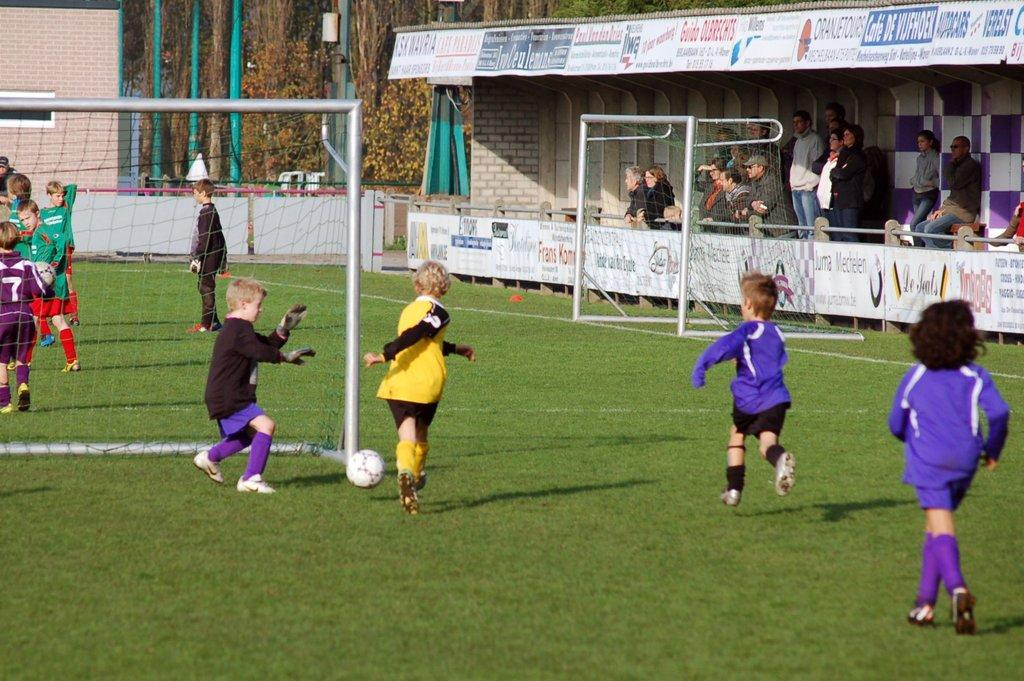Provide a one-sentence caption for the provided image. A boy in a purple soccer uniform with number 7 stands behind the goal. 